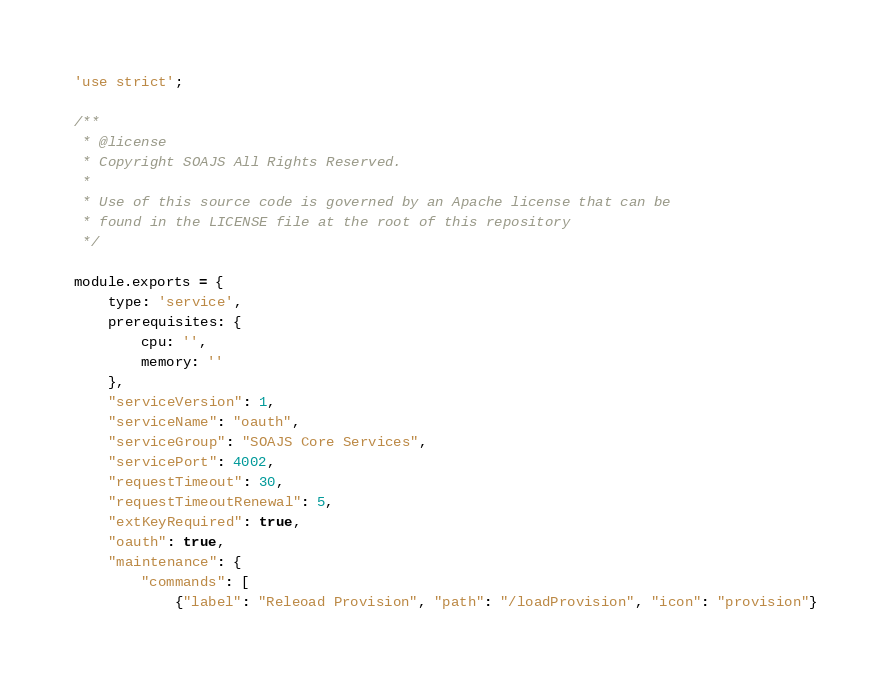<code> <loc_0><loc_0><loc_500><loc_500><_JavaScript_>'use strict';

/**
 * @license
 * Copyright SOAJS All Rights Reserved.
 *
 * Use of this source code is governed by an Apache license that can be
 * found in the LICENSE file at the root of this repository
 */

module.exports = {
	type: 'service',
	prerequisites: {
		cpu: '',
		memory: ''
	},
	"serviceVersion": 1,
	"serviceName": "oauth",
	"serviceGroup": "SOAJS Core Services",
	"servicePort": 4002,
	"requestTimeout": 30,
	"requestTimeoutRenewal": 5,
	"extKeyRequired": true,
	"oauth": true,
	"maintenance": {
		"commands": [
			{"label": "Releoad Provision", "path": "/loadProvision", "icon": "provision"}</code> 